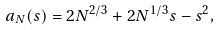<formula> <loc_0><loc_0><loc_500><loc_500>a _ { N } ( s ) = 2 N ^ { 2 / 3 } + 2 N ^ { 1 / 3 } s - s ^ { 2 } ,</formula> 